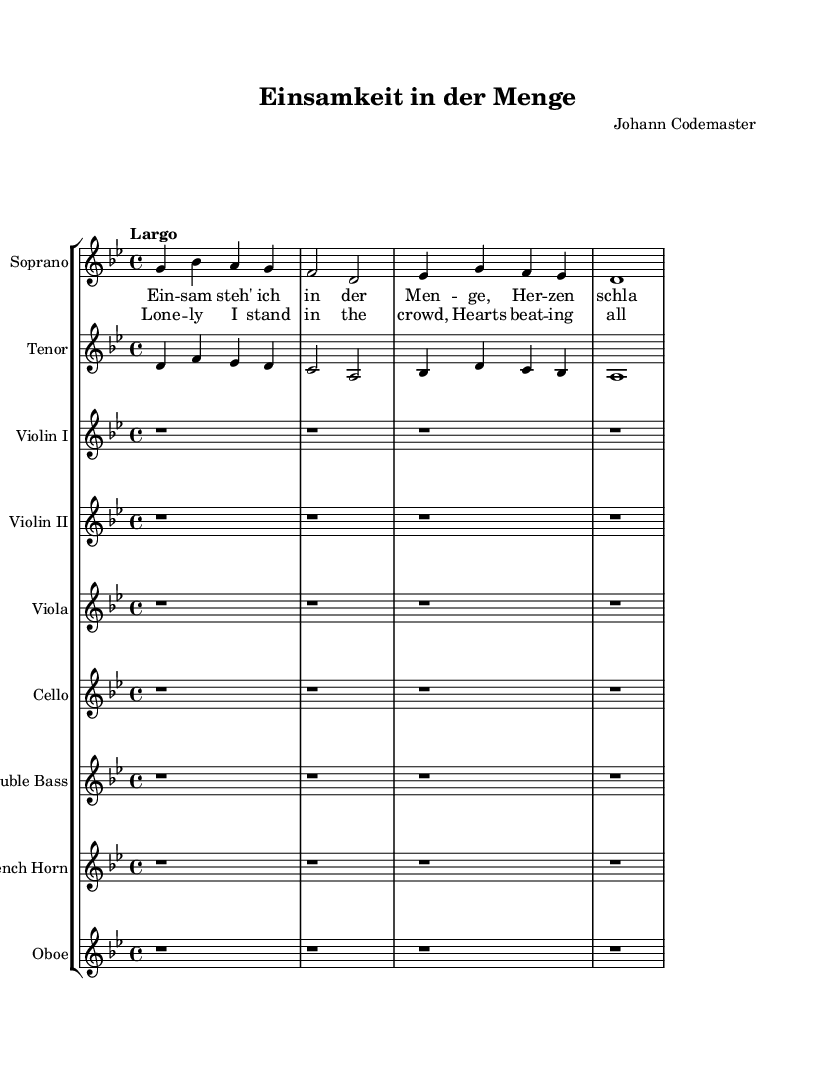What is the key signature of this music? The key signature is indicated by the number of sharps or flats at the beginning of the staff. Here, the first line has the 'B flat' symbol, indicating B flat major or G minor.
Answer: G minor What is the time signature of this music? The time signature appears at the beginning of the staff and shows how many beats are in each measure. Here, it is 4/4, meaning there are four beats in each measure.
Answer: 4/4 What is the tempo marking for this piece? The tempo marking is specified near the beginning and indicates how fast the music should be played. Here, it is marked as "Largo", which is a slow tempo.
Answer: Largo How many voices are present in the opera section? The number of voices can be counted in the score. Here, there are two designated voices: Soprano and Tenor.
Answer: Two What is the translation of the German lyric "Ein -- sam steh' ich in der Men -- ge"? To find the translation, one looks at the English lyrics provided in alignment with the German lyrics. "Ein -- sam steh' ich in der Men -- ge" translates to "Lone -- ly I stand in the crowd."
Answer: Lone -- ly I stand in the crowd Which instrument is playing the melody along with the soprano? By observing the vocal parts and their interplay with the instrumentation, it's clear that the melody primarily aligns with the Soprano voice, whereas the Tenor has tasks aligned with counterpoints. However, no instrument except voices share the melody directly with the Soprano; others form harmonies.
Answer: Soprano How is the emotional tone represented in the music through tempo and key? The emotional tone can be inferred through the choice of tempo and key signature. A slower tempo (Largo) and a minor key (G minor) typically evoke feelings of sadness or introspection, conveying the theme of isolation and complexity in human relationships.
Answer: Sadness 